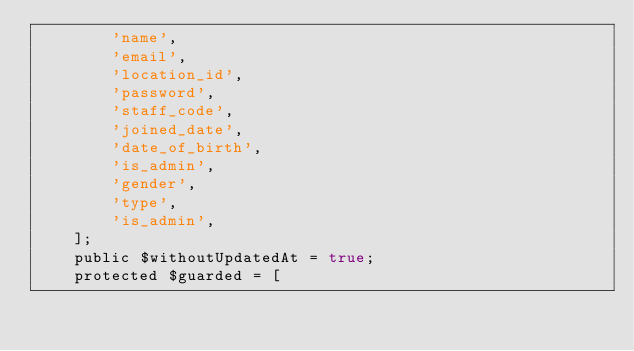Convert code to text. <code><loc_0><loc_0><loc_500><loc_500><_PHP_>        'name',
        'email',
        'location_id',
        'password',
        'staff_code',
        'joined_date',
        'date_of_birth',
        'is_admin',
        'gender',
        'type',
        'is_admin',
    ];
    public $withoutUpdatedAt = true;
    protected $guarded = [

</code> 